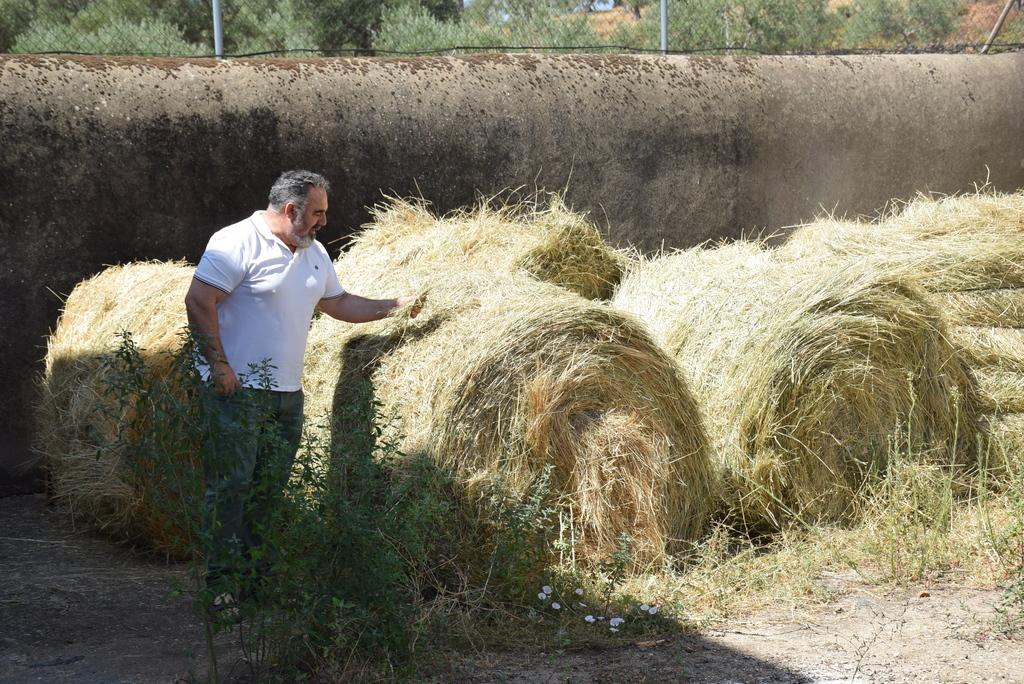Please provide a concise description of this image. In the picture we can see a man standing in a white T-shirt and touching the dried grass and near him we can also see the plant and in the background, we can see the wall with a fencing on it and from the fencing we can see some plants. 